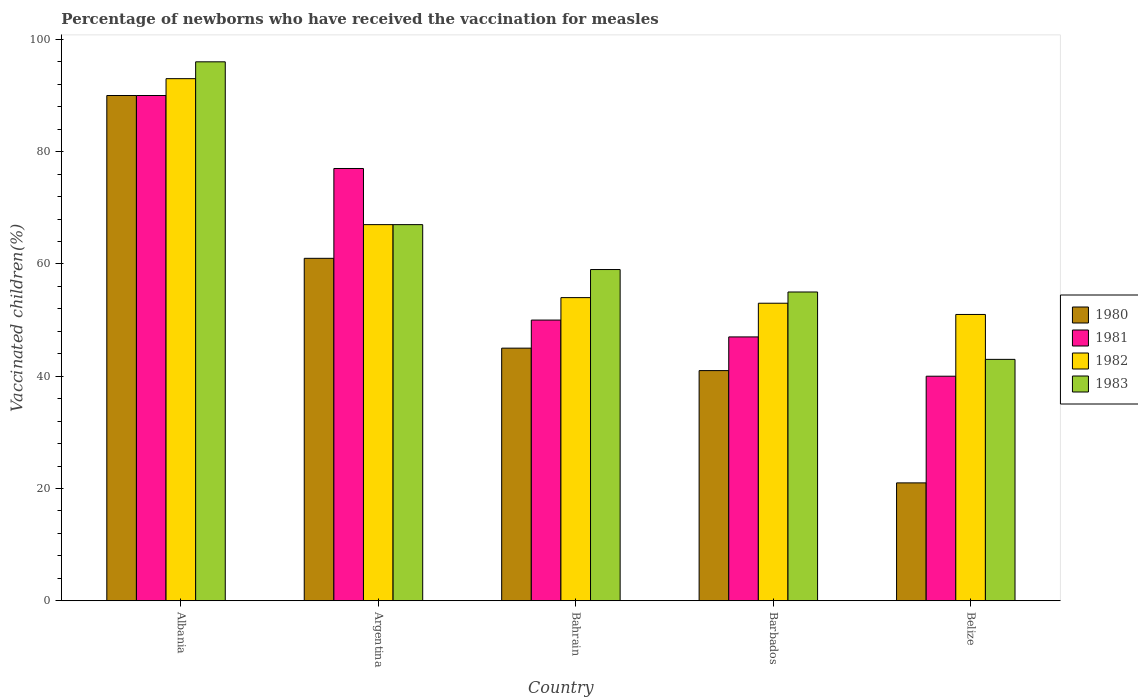How many different coloured bars are there?
Provide a short and direct response. 4. How many bars are there on the 5th tick from the left?
Make the answer very short. 4. How many bars are there on the 5th tick from the right?
Keep it short and to the point. 4. What is the label of the 4th group of bars from the left?
Your answer should be very brief. Barbados. What is the percentage of vaccinated children in 1982 in Barbados?
Offer a very short reply. 53. Across all countries, what is the maximum percentage of vaccinated children in 1983?
Offer a terse response. 96. In which country was the percentage of vaccinated children in 1981 maximum?
Make the answer very short. Albania. In which country was the percentage of vaccinated children in 1982 minimum?
Your response must be concise. Belize. What is the total percentage of vaccinated children in 1981 in the graph?
Make the answer very short. 304. What is the difference between the percentage of vaccinated children in 1981 in Argentina and that in Bahrain?
Your answer should be compact. 27. What is the difference between the percentage of vaccinated children in 1980 in Barbados and the percentage of vaccinated children in 1982 in Belize?
Provide a short and direct response. -10. What is the average percentage of vaccinated children in 1981 per country?
Give a very brief answer. 60.8. What is the difference between the percentage of vaccinated children of/in 1982 and percentage of vaccinated children of/in 1980 in Belize?
Offer a terse response. 30. What is the ratio of the percentage of vaccinated children in 1982 in Albania to that in Argentina?
Provide a short and direct response. 1.39. Is the percentage of vaccinated children in 1982 in Barbados less than that in Belize?
Keep it short and to the point. No. Is the difference between the percentage of vaccinated children in 1982 in Albania and Argentina greater than the difference between the percentage of vaccinated children in 1980 in Albania and Argentina?
Provide a short and direct response. No. What is the difference between the highest and the second highest percentage of vaccinated children in 1981?
Provide a short and direct response. 40. What is the difference between the highest and the lowest percentage of vaccinated children in 1980?
Provide a short and direct response. 69. In how many countries, is the percentage of vaccinated children in 1980 greater than the average percentage of vaccinated children in 1980 taken over all countries?
Your response must be concise. 2. Is it the case that in every country, the sum of the percentage of vaccinated children in 1982 and percentage of vaccinated children in 1983 is greater than the sum of percentage of vaccinated children in 1981 and percentage of vaccinated children in 1980?
Offer a very short reply. No. What does the 2nd bar from the right in Albania represents?
Your answer should be compact. 1982. Is it the case that in every country, the sum of the percentage of vaccinated children in 1981 and percentage of vaccinated children in 1980 is greater than the percentage of vaccinated children in 1982?
Offer a very short reply. Yes. How many countries are there in the graph?
Your answer should be very brief. 5. What is the difference between two consecutive major ticks on the Y-axis?
Keep it short and to the point. 20. Are the values on the major ticks of Y-axis written in scientific E-notation?
Offer a terse response. No. Does the graph contain grids?
Provide a short and direct response. No. How many legend labels are there?
Offer a terse response. 4. How are the legend labels stacked?
Your answer should be compact. Vertical. What is the title of the graph?
Offer a very short reply. Percentage of newborns who have received the vaccination for measles. What is the label or title of the Y-axis?
Your answer should be compact. Vaccinated children(%). What is the Vaccinated children(%) of 1980 in Albania?
Give a very brief answer. 90. What is the Vaccinated children(%) in 1982 in Albania?
Offer a terse response. 93. What is the Vaccinated children(%) in 1983 in Albania?
Offer a very short reply. 96. What is the Vaccinated children(%) in 1981 in Argentina?
Your answer should be compact. 77. What is the Vaccinated children(%) of 1982 in Argentina?
Make the answer very short. 67. What is the Vaccinated children(%) in 1980 in Bahrain?
Provide a succinct answer. 45. What is the Vaccinated children(%) in 1981 in Bahrain?
Ensure brevity in your answer.  50. What is the Vaccinated children(%) in 1980 in Barbados?
Provide a short and direct response. 41. What is the Vaccinated children(%) of 1981 in Barbados?
Ensure brevity in your answer.  47. What is the Vaccinated children(%) of 1983 in Barbados?
Ensure brevity in your answer.  55. What is the Vaccinated children(%) of 1983 in Belize?
Ensure brevity in your answer.  43. Across all countries, what is the maximum Vaccinated children(%) of 1980?
Offer a very short reply. 90. Across all countries, what is the maximum Vaccinated children(%) in 1982?
Your answer should be compact. 93. Across all countries, what is the maximum Vaccinated children(%) in 1983?
Offer a terse response. 96. Across all countries, what is the minimum Vaccinated children(%) in 1982?
Keep it short and to the point. 51. Across all countries, what is the minimum Vaccinated children(%) in 1983?
Your answer should be very brief. 43. What is the total Vaccinated children(%) of 1980 in the graph?
Your answer should be very brief. 258. What is the total Vaccinated children(%) in 1981 in the graph?
Provide a short and direct response. 304. What is the total Vaccinated children(%) in 1982 in the graph?
Offer a terse response. 318. What is the total Vaccinated children(%) in 1983 in the graph?
Provide a succinct answer. 320. What is the difference between the Vaccinated children(%) of 1981 in Albania and that in Argentina?
Your answer should be compact. 13. What is the difference between the Vaccinated children(%) of 1982 in Albania and that in Argentina?
Keep it short and to the point. 26. What is the difference between the Vaccinated children(%) in 1983 in Albania and that in Argentina?
Ensure brevity in your answer.  29. What is the difference between the Vaccinated children(%) of 1980 in Albania and that in Bahrain?
Offer a terse response. 45. What is the difference between the Vaccinated children(%) of 1981 in Albania and that in Bahrain?
Provide a succinct answer. 40. What is the difference between the Vaccinated children(%) in 1983 in Albania and that in Bahrain?
Give a very brief answer. 37. What is the difference between the Vaccinated children(%) in 1981 in Albania and that in Barbados?
Make the answer very short. 43. What is the difference between the Vaccinated children(%) of 1982 in Albania and that in Barbados?
Offer a very short reply. 40. What is the difference between the Vaccinated children(%) in 1982 in Albania and that in Belize?
Give a very brief answer. 42. What is the difference between the Vaccinated children(%) in 1982 in Argentina and that in Bahrain?
Provide a succinct answer. 13. What is the difference between the Vaccinated children(%) of 1983 in Argentina and that in Bahrain?
Provide a short and direct response. 8. What is the difference between the Vaccinated children(%) of 1980 in Argentina and that in Barbados?
Give a very brief answer. 20. What is the difference between the Vaccinated children(%) in 1981 in Argentina and that in Barbados?
Make the answer very short. 30. What is the difference between the Vaccinated children(%) in 1982 in Argentina and that in Barbados?
Keep it short and to the point. 14. What is the difference between the Vaccinated children(%) in 1980 in Argentina and that in Belize?
Ensure brevity in your answer.  40. What is the difference between the Vaccinated children(%) of 1983 in Argentina and that in Belize?
Your answer should be very brief. 24. What is the difference between the Vaccinated children(%) of 1980 in Bahrain and that in Barbados?
Ensure brevity in your answer.  4. What is the difference between the Vaccinated children(%) of 1982 in Bahrain and that in Barbados?
Offer a very short reply. 1. What is the difference between the Vaccinated children(%) of 1980 in Bahrain and that in Belize?
Keep it short and to the point. 24. What is the difference between the Vaccinated children(%) in 1981 in Bahrain and that in Belize?
Make the answer very short. 10. What is the difference between the Vaccinated children(%) in 1982 in Bahrain and that in Belize?
Ensure brevity in your answer.  3. What is the difference between the Vaccinated children(%) in 1981 in Barbados and that in Belize?
Your answer should be compact. 7. What is the difference between the Vaccinated children(%) in 1983 in Barbados and that in Belize?
Provide a short and direct response. 12. What is the difference between the Vaccinated children(%) of 1980 in Albania and the Vaccinated children(%) of 1982 in Argentina?
Give a very brief answer. 23. What is the difference between the Vaccinated children(%) of 1981 in Albania and the Vaccinated children(%) of 1983 in Argentina?
Give a very brief answer. 23. What is the difference between the Vaccinated children(%) of 1982 in Albania and the Vaccinated children(%) of 1983 in Argentina?
Your answer should be very brief. 26. What is the difference between the Vaccinated children(%) of 1980 in Albania and the Vaccinated children(%) of 1982 in Bahrain?
Ensure brevity in your answer.  36. What is the difference between the Vaccinated children(%) in 1980 in Albania and the Vaccinated children(%) in 1983 in Bahrain?
Your response must be concise. 31. What is the difference between the Vaccinated children(%) in 1981 in Albania and the Vaccinated children(%) in 1982 in Bahrain?
Ensure brevity in your answer.  36. What is the difference between the Vaccinated children(%) in 1980 in Albania and the Vaccinated children(%) in 1982 in Barbados?
Provide a short and direct response. 37. What is the difference between the Vaccinated children(%) in 1980 in Albania and the Vaccinated children(%) in 1983 in Barbados?
Provide a short and direct response. 35. What is the difference between the Vaccinated children(%) of 1981 in Albania and the Vaccinated children(%) of 1982 in Barbados?
Offer a terse response. 37. What is the difference between the Vaccinated children(%) of 1980 in Albania and the Vaccinated children(%) of 1981 in Belize?
Make the answer very short. 50. What is the difference between the Vaccinated children(%) in 1980 in Albania and the Vaccinated children(%) in 1982 in Belize?
Your response must be concise. 39. What is the difference between the Vaccinated children(%) of 1981 in Albania and the Vaccinated children(%) of 1983 in Belize?
Offer a very short reply. 47. What is the difference between the Vaccinated children(%) in 1980 in Argentina and the Vaccinated children(%) in 1981 in Bahrain?
Make the answer very short. 11. What is the difference between the Vaccinated children(%) in 1980 in Argentina and the Vaccinated children(%) in 1982 in Bahrain?
Your response must be concise. 7. What is the difference between the Vaccinated children(%) of 1980 in Argentina and the Vaccinated children(%) of 1983 in Bahrain?
Make the answer very short. 2. What is the difference between the Vaccinated children(%) in 1982 in Argentina and the Vaccinated children(%) in 1983 in Bahrain?
Provide a short and direct response. 8. What is the difference between the Vaccinated children(%) in 1981 in Argentina and the Vaccinated children(%) in 1982 in Barbados?
Make the answer very short. 24. What is the difference between the Vaccinated children(%) of 1981 in Argentina and the Vaccinated children(%) of 1983 in Barbados?
Give a very brief answer. 22. What is the difference between the Vaccinated children(%) of 1980 in Argentina and the Vaccinated children(%) of 1983 in Belize?
Provide a succinct answer. 18. What is the difference between the Vaccinated children(%) of 1981 in Argentina and the Vaccinated children(%) of 1982 in Belize?
Provide a succinct answer. 26. What is the difference between the Vaccinated children(%) in 1981 in Argentina and the Vaccinated children(%) in 1983 in Belize?
Provide a short and direct response. 34. What is the difference between the Vaccinated children(%) in 1982 in Argentina and the Vaccinated children(%) in 1983 in Belize?
Provide a short and direct response. 24. What is the difference between the Vaccinated children(%) in 1980 in Bahrain and the Vaccinated children(%) in 1981 in Barbados?
Ensure brevity in your answer.  -2. What is the difference between the Vaccinated children(%) of 1981 in Bahrain and the Vaccinated children(%) of 1983 in Barbados?
Offer a very short reply. -5. What is the difference between the Vaccinated children(%) of 1982 in Bahrain and the Vaccinated children(%) of 1983 in Barbados?
Provide a succinct answer. -1. What is the difference between the Vaccinated children(%) in 1980 in Bahrain and the Vaccinated children(%) in 1981 in Belize?
Give a very brief answer. 5. What is the difference between the Vaccinated children(%) of 1981 in Bahrain and the Vaccinated children(%) of 1982 in Belize?
Your answer should be very brief. -1. What is the difference between the Vaccinated children(%) in 1982 in Bahrain and the Vaccinated children(%) in 1983 in Belize?
Make the answer very short. 11. What is the difference between the Vaccinated children(%) of 1980 in Barbados and the Vaccinated children(%) of 1982 in Belize?
Your response must be concise. -10. What is the difference between the Vaccinated children(%) in 1980 in Barbados and the Vaccinated children(%) in 1983 in Belize?
Offer a terse response. -2. What is the difference between the Vaccinated children(%) of 1982 in Barbados and the Vaccinated children(%) of 1983 in Belize?
Your response must be concise. 10. What is the average Vaccinated children(%) of 1980 per country?
Provide a succinct answer. 51.6. What is the average Vaccinated children(%) of 1981 per country?
Offer a very short reply. 60.8. What is the average Vaccinated children(%) of 1982 per country?
Offer a terse response. 63.6. What is the difference between the Vaccinated children(%) of 1980 and Vaccinated children(%) of 1981 in Albania?
Offer a terse response. 0. What is the difference between the Vaccinated children(%) in 1980 and Vaccinated children(%) in 1982 in Albania?
Ensure brevity in your answer.  -3. What is the difference between the Vaccinated children(%) of 1980 and Vaccinated children(%) of 1983 in Albania?
Your answer should be compact. -6. What is the difference between the Vaccinated children(%) in 1981 and Vaccinated children(%) in 1982 in Albania?
Keep it short and to the point. -3. What is the difference between the Vaccinated children(%) of 1982 and Vaccinated children(%) of 1983 in Albania?
Your answer should be compact. -3. What is the difference between the Vaccinated children(%) of 1980 and Vaccinated children(%) of 1981 in Argentina?
Make the answer very short. -16. What is the difference between the Vaccinated children(%) of 1981 and Vaccinated children(%) of 1982 in Argentina?
Provide a short and direct response. 10. What is the difference between the Vaccinated children(%) in 1981 and Vaccinated children(%) in 1983 in Argentina?
Provide a short and direct response. 10. What is the difference between the Vaccinated children(%) in 1982 and Vaccinated children(%) in 1983 in Argentina?
Your response must be concise. 0. What is the difference between the Vaccinated children(%) of 1980 and Vaccinated children(%) of 1981 in Bahrain?
Offer a terse response. -5. What is the difference between the Vaccinated children(%) of 1981 and Vaccinated children(%) of 1982 in Bahrain?
Offer a very short reply. -4. What is the difference between the Vaccinated children(%) of 1981 and Vaccinated children(%) of 1983 in Bahrain?
Give a very brief answer. -9. What is the difference between the Vaccinated children(%) in 1982 and Vaccinated children(%) in 1983 in Bahrain?
Ensure brevity in your answer.  -5. What is the difference between the Vaccinated children(%) of 1980 and Vaccinated children(%) of 1983 in Barbados?
Offer a terse response. -14. What is the difference between the Vaccinated children(%) in 1981 and Vaccinated children(%) in 1982 in Barbados?
Make the answer very short. -6. What is the difference between the Vaccinated children(%) in 1982 and Vaccinated children(%) in 1983 in Barbados?
Ensure brevity in your answer.  -2. What is the difference between the Vaccinated children(%) of 1980 and Vaccinated children(%) of 1982 in Belize?
Ensure brevity in your answer.  -30. What is the difference between the Vaccinated children(%) in 1981 and Vaccinated children(%) in 1982 in Belize?
Your response must be concise. -11. What is the ratio of the Vaccinated children(%) in 1980 in Albania to that in Argentina?
Your answer should be compact. 1.48. What is the ratio of the Vaccinated children(%) in 1981 in Albania to that in Argentina?
Ensure brevity in your answer.  1.17. What is the ratio of the Vaccinated children(%) of 1982 in Albania to that in Argentina?
Give a very brief answer. 1.39. What is the ratio of the Vaccinated children(%) of 1983 in Albania to that in Argentina?
Offer a very short reply. 1.43. What is the ratio of the Vaccinated children(%) in 1982 in Albania to that in Bahrain?
Offer a terse response. 1.72. What is the ratio of the Vaccinated children(%) of 1983 in Albania to that in Bahrain?
Ensure brevity in your answer.  1.63. What is the ratio of the Vaccinated children(%) of 1980 in Albania to that in Barbados?
Make the answer very short. 2.2. What is the ratio of the Vaccinated children(%) in 1981 in Albania to that in Barbados?
Give a very brief answer. 1.91. What is the ratio of the Vaccinated children(%) in 1982 in Albania to that in Barbados?
Ensure brevity in your answer.  1.75. What is the ratio of the Vaccinated children(%) in 1983 in Albania to that in Barbados?
Ensure brevity in your answer.  1.75. What is the ratio of the Vaccinated children(%) in 1980 in Albania to that in Belize?
Ensure brevity in your answer.  4.29. What is the ratio of the Vaccinated children(%) in 1981 in Albania to that in Belize?
Offer a terse response. 2.25. What is the ratio of the Vaccinated children(%) in 1982 in Albania to that in Belize?
Give a very brief answer. 1.82. What is the ratio of the Vaccinated children(%) of 1983 in Albania to that in Belize?
Your answer should be compact. 2.23. What is the ratio of the Vaccinated children(%) of 1980 in Argentina to that in Bahrain?
Offer a very short reply. 1.36. What is the ratio of the Vaccinated children(%) of 1981 in Argentina to that in Bahrain?
Your answer should be compact. 1.54. What is the ratio of the Vaccinated children(%) in 1982 in Argentina to that in Bahrain?
Your answer should be very brief. 1.24. What is the ratio of the Vaccinated children(%) of 1983 in Argentina to that in Bahrain?
Keep it short and to the point. 1.14. What is the ratio of the Vaccinated children(%) in 1980 in Argentina to that in Barbados?
Provide a succinct answer. 1.49. What is the ratio of the Vaccinated children(%) in 1981 in Argentina to that in Barbados?
Offer a terse response. 1.64. What is the ratio of the Vaccinated children(%) in 1982 in Argentina to that in Barbados?
Your answer should be compact. 1.26. What is the ratio of the Vaccinated children(%) of 1983 in Argentina to that in Barbados?
Make the answer very short. 1.22. What is the ratio of the Vaccinated children(%) in 1980 in Argentina to that in Belize?
Give a very brief answer. 2.9. What is the ratio of the Vaccinated children(%) in 1981 in Argentina to that in Belize?
Ensure brevity in your answer.  1.93. What is the ratio of the Vaccinated children(%) in 1982 in Argentina to that in Belize?
Offer a very short reply. 1.31. What is the ratio of the Vaccinated children(%) in 1983 in Argentina to that in Belize?
Make the answer very short. 1.56. What is the ratio of the Vaccinated children(%) in 1980 in Bahrain to that in Barbados?
Make the answer very short. 1.1. What is the ratio of the Vaccinated children(%) in 1981 in Bahrain to that in Barbados?
Ensure brevity in your answer.  1.06. What is the ratio of the Vaccinated children(%) of 1982 in Bahrain to that in Barbados?
Provide a succinct answer. 1.02. What is the ratio of the Vaccinated children(%) of 1983 in Bahrain to that in Barbados?
Your response must be concise. 1.07. What is the ratio of the Vaccinated children(%) in 1980 in Bahrain to that in Belize?
Your response must be concise. 2.14. What is the ratio of the Vaccinated children(%) of 1981 in Bahrain to that in Belize?
Keep it short and to the point. 1.25. What is the ratio of the Vaccinated children(%) in 1982 in Bahrain to that in Belize?
Make the answer very short. 1.06. What is the ratio of the Vaccinated children(%) of 1983 in Bahrain to that in Belize?
Offer a very short reply. 1.37. What is the ratio of the Vaccinated children(%) of 1980 in Barbados to that in Belize?
Keep it short and to the point. 1.95. What is the ratio of the Vaccinated children(%) of 1981 in Barbados to that in Belize?
Provide a short and direct response. 1.18. What is the ratio of the Vaccinated children(%) of 1982 in Barbados to that in Belize?
Give a very brief answer. 1.04. What is the ratio of the Vaccinated children(%) in 1983 in Barbados to that in Belize?
Provide a succinct answer. 1.28. What is the difference between the highest and the second highest Vaccinated children(%) in 1983?
Offer a very short reply. 29. What is the difference between the highest and the lowest Vaccinated children(%) of 1981?
Your answer should be very brief. 50. What is the difference between the highest and the lowest Vaccinated children(%) of 1983?
Give a very brief answer. 53. 